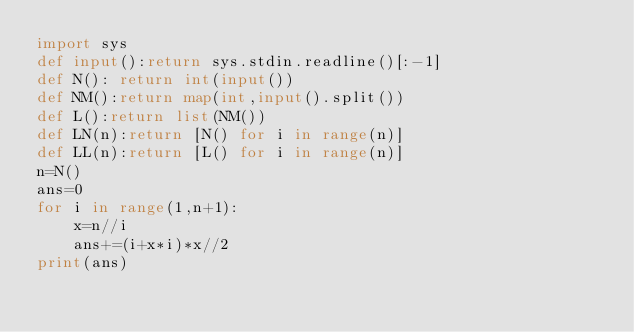<code> <loc_0><loc_0><loc_500><loc_500><_Python_>import sys
def input():return sys.stdin.readline()[:-1]
def N(): return int(input())
def NM():return map(int,input().split())
def L():return list(NM())
def LN(n):return [N() for i in range(n)]
def LL(n):return [L() for i in range(n)]
n=N()
ans=0
for i in range(1,n+1):
    x=n//i
    ans+=(i+x*i)*x//2
print(ans)</code> 